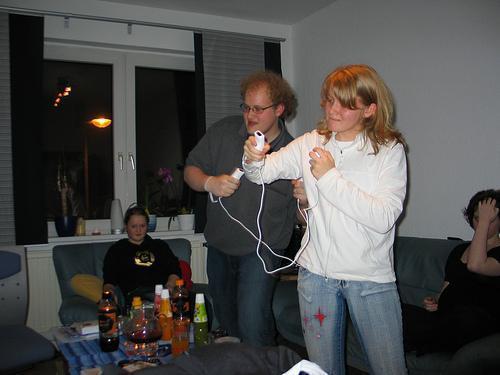How many people are playing a video game?
Give a very brief answer. 2. How many players are in white?
Give a very brief answer. 1. How many people are playing wii?
Give a very brief answer. 2. 